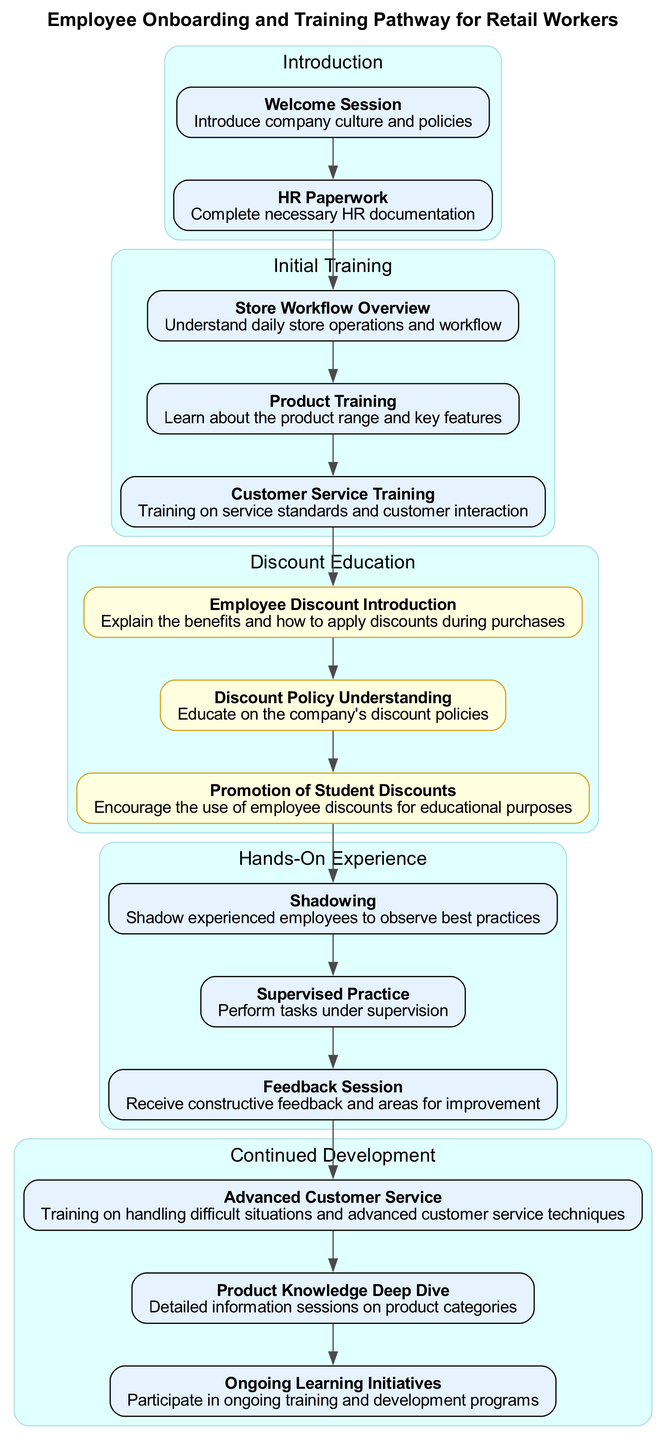What is the first step in the Onboarding Process? The first step in the Onboarding Process, as represented in the diagram, is the "Welcome Session," which introduces the company culture and policies.
Answer: Welcome Session How many steps are in the Initial Training section? The Initial Training section contains three steps: "Store Workflow Overview," "Product Training," and "Customer Service Training." Counting these gives a total of three steps.
Answer: 3 Which section immediately follows the Discount Education section? The section that immediately follows the Discount Education section is "Hands-On Experience," indicating the progression of the pathway.
Answer: Hands-On Experience What is the main focus of the Continued Development section? The main focus of the Continued Development section is on enhancing skills and knowledge, specifically through training on advanced customer service and ongoing learning initiatives.
Answer: Enhancing skills How many nodes are in the Discount Education section? The Discount Education section consists of three distinct nodes: "Employee Discount Introduction," "Discount Policy Understanding," and "Promotion of Student Discounts." Therefore, there are three nodes in this section.
Answer: 3 What are the benefits highlighted in the Discount Education section? The benefits highlighted in this section are related to understanding employee discounts and encouraging the use of these discounts, particularly for educational purposes.
Answer: Employee discounts What training follows the "Customer Service Training" step? Following the "Customer Service Training" step, the next step in the pathway is "Discount Education," showcasing the importance of understanding discount policies right after customer service methods.
Answer: Discount Education What is the last step of the Hands-On Experience section? The last step of the Hands-On Experience section is the "Feedback Session," where employees receive constructive feedback for improvement.
Answer: Feedback Session How does "Shadowing" contribute to the training pathway? "Shadowing" allows new employees to observe experienced staff and learn best practices, making it an integral part of hands-on experience and practical training.
Answer: Observing best practices 